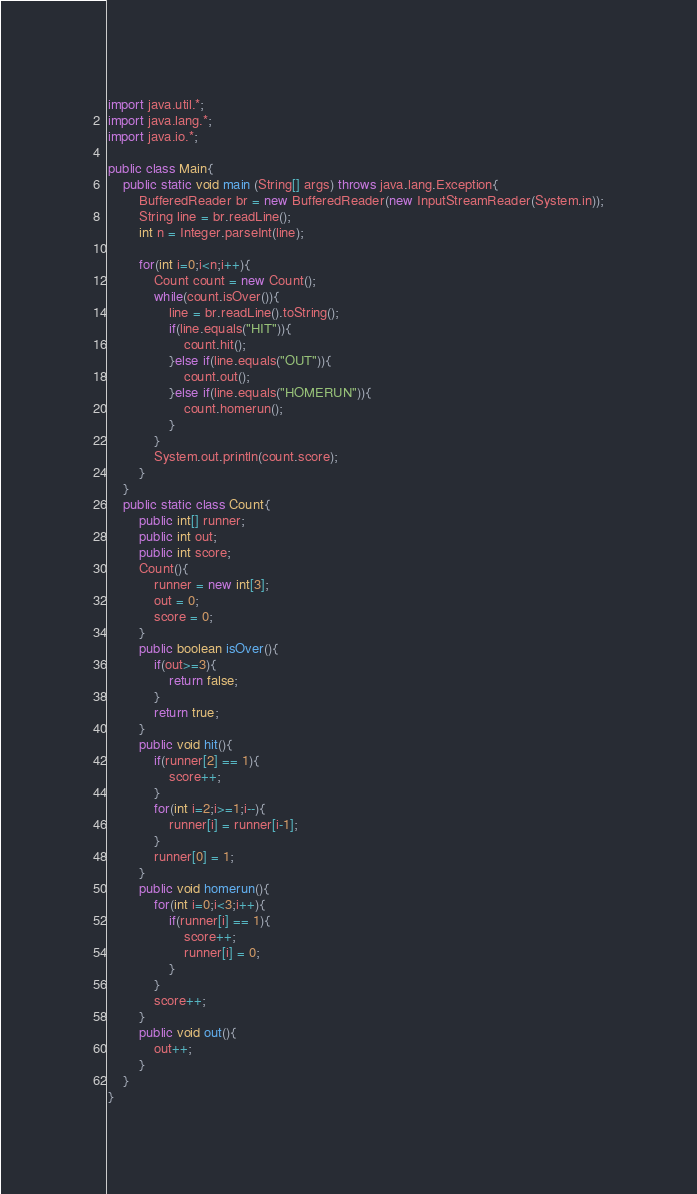<code> <loc_0><loc_0><loc_500><loc_500><_Java_>import java.util.*;
import java.lang.*;
import java.io.*;

public class Main{
	public static void main (String[] args) throws java.lang.Exception{
		BufferedReader br = new BufferedReader(new InputStreamReader(System.in));
		String line = br.readLine();
	    int n = Integer.parseInt(line);
	    
	    for(int i=0;i<n;i++){
	        Count count = new Count();
	        while(count.isOver()){
	            line = br.readLine().toString();
	            if(line.equals("HIT")){
	                count.hit();
	            }else if(line.equals("OUT")){
	                count.out();
	            }else if(line.equals("HOMERUN")){
	                count.homerun();
	            }
	        }
    		System.out.println(count.score);
	    }
	}
    public static class Count{
        public int[] runner;
        public int out;
        public int score;
        Count(){
            runner = new int[3];
            out = 0;
            score = 0;
        }
        public boolean isOver(){
            if(out>=3){
                return false;
            }
            return true;
        }
        public void hit(){
            if(runner[2] == 1){
                score++;
            }
            for(int i=2;i>=1;i--){
                runner[i] = runner[i-1];
            }
            runner[0] = 1;
        }
        public void homerun(){
            for(int i=0;i<3;i++){
                if(runner[i] == 1){
                    score++;
                    runner[i] = 0;
                }
            }
            score++;
        }
        public void out(){
            out++;
        }
    }
}</code> 